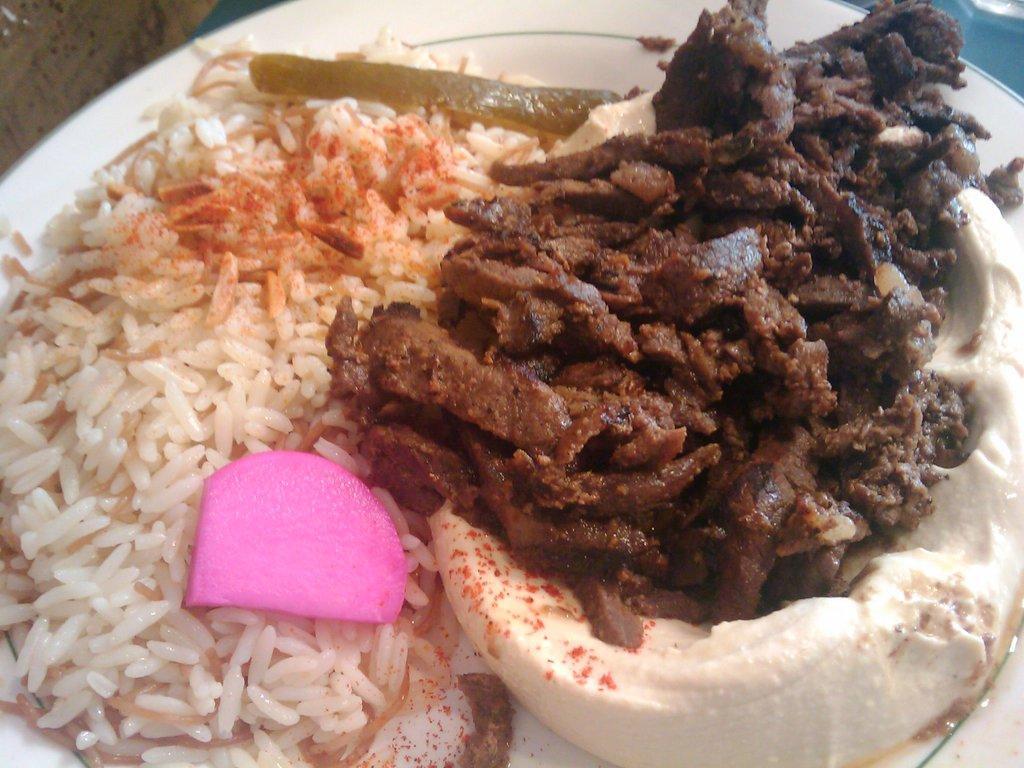Please provide a concise description of this image. In this image I see the white plate on which there is rice and I see other food item which is of white and brown in color and I see the pink color thing over here. 